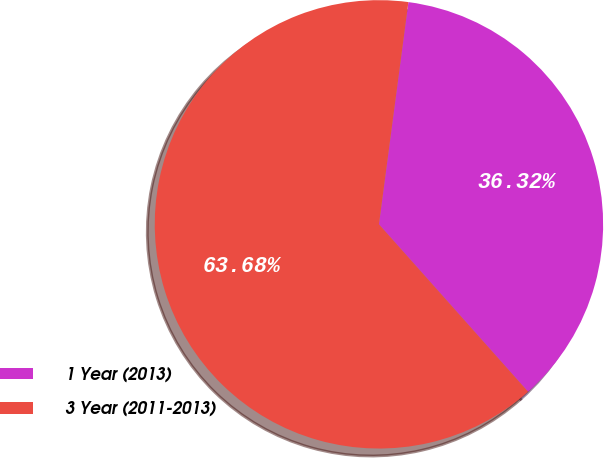Convert chart to OTSL. <chart><loc_0><loc_0><loc_500><loc_500><pie_chart><fcel>1 Year (2013)<fcel>3 Year (2011-2013)<nl><fcel>36.32%<fcel>63.68%<nl></chart> 